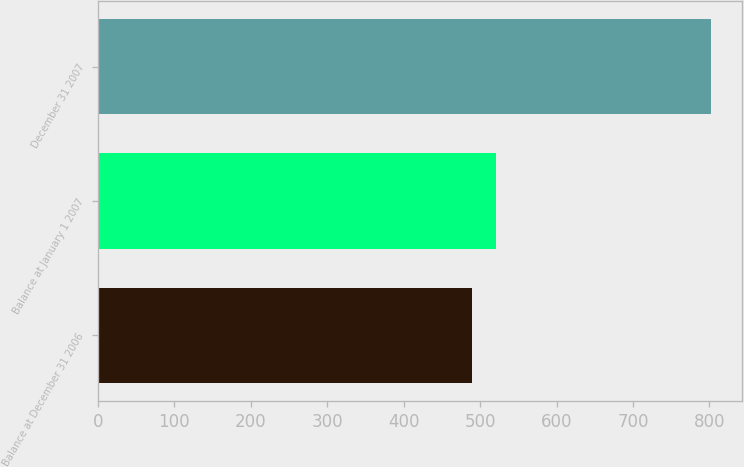<chart> <loc_0><loc_0><loc_500><loc_500><bar_chart><fcel>Balance at December 31 2006<fcel>Balance at January 1 2007<fcel>December 31 2007<nl><fcel>489<fcel>520.3<fcel>802<nl></chart> 